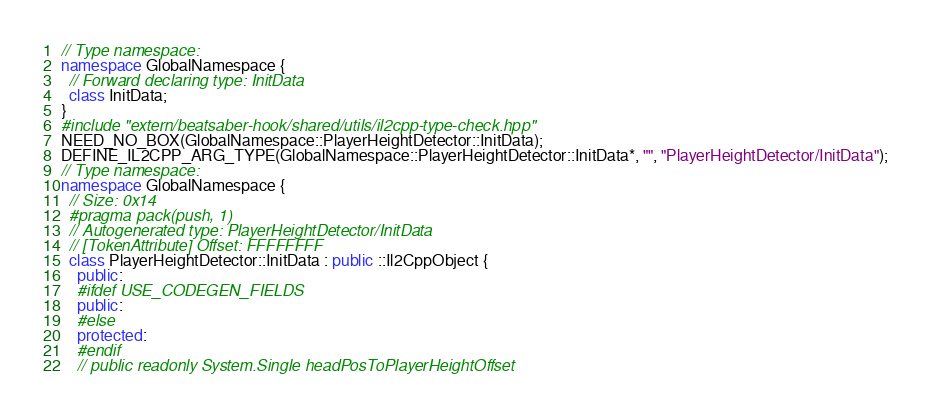<code> <loc_0><loc_0><loc_500><loc_500><_C++_>// Type namespace: 
namespace GlobalNamespace {
  // Forward declaring type: InitData
  class InitData;
}
#include "extern/beatsaber-hook/shared/utils/il2cpp-type-check.hpp"
NEED_NO_BOX(GlobalNamespace::PlayerHeightDetector::InitData);
DEFINE_IL2CPP_ARG_TYPE(GlobalNamespace::PlayerHeightDetector::InitData*, "", "PlayerHeightDetector/InitData");
// Type namespace: 
namespace GlobalNamespace {
  // Size: 0x14
  #pragma pack(push, 1)
  // Autogenerated type: PlayerHeightDetector/InitData
  // [TokenAttribute] Offset: FFFFFFFF
  class PlayerHeightDetector::InitData : public ::Il2CppObject {
    public:
    #ifdef USE_CODEGEN_FIELDS
    public:
    #else
    protected:
    #endif
    // public readonly System.Single headPosToPlayerHeightOffset</code> 